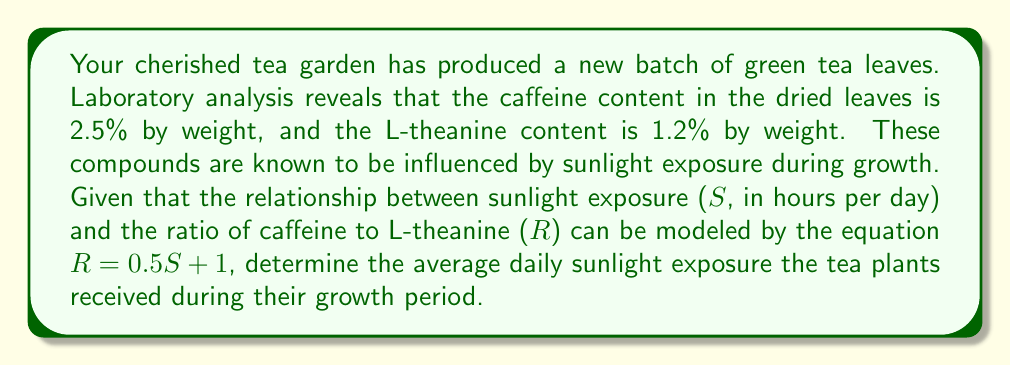Provide a solution to this math problem. Let's approach this step-by-step:

1) First, we need to calculate the ratio of caffeine to L-theanine (R) in the tea leaves:
   
   $R = \frac{\text{Caffeine content}}{\text{L-theanine content}} = \frac{2.5\%}{1.2\%} = \frac{2.5}{1.2} \approx 2.0833$

2) Now, we have the equation relating sunlight exposure (S) to the ratio (R):
   
   $R = 0.5S + 1$

3) We can substitute our calculated R value into this equation:
   
   $2.0833 = 0.5S + 1$

4) To solve for S, we first subtract 1 from both sides:
   
   $1.0833 = 0.5S$

5) Then, we multiply both sides by 2 to isolate S:
   
   $2.1666 = S$

6) Rounding to a reasonable precision for daily sunlight hours:
   
   $S \approx 2.17$ hours

Therefore, the tea plants received an average of approximately 2.17 hours of sunlight per day during their growth period.
Answer: 2.17 hours 